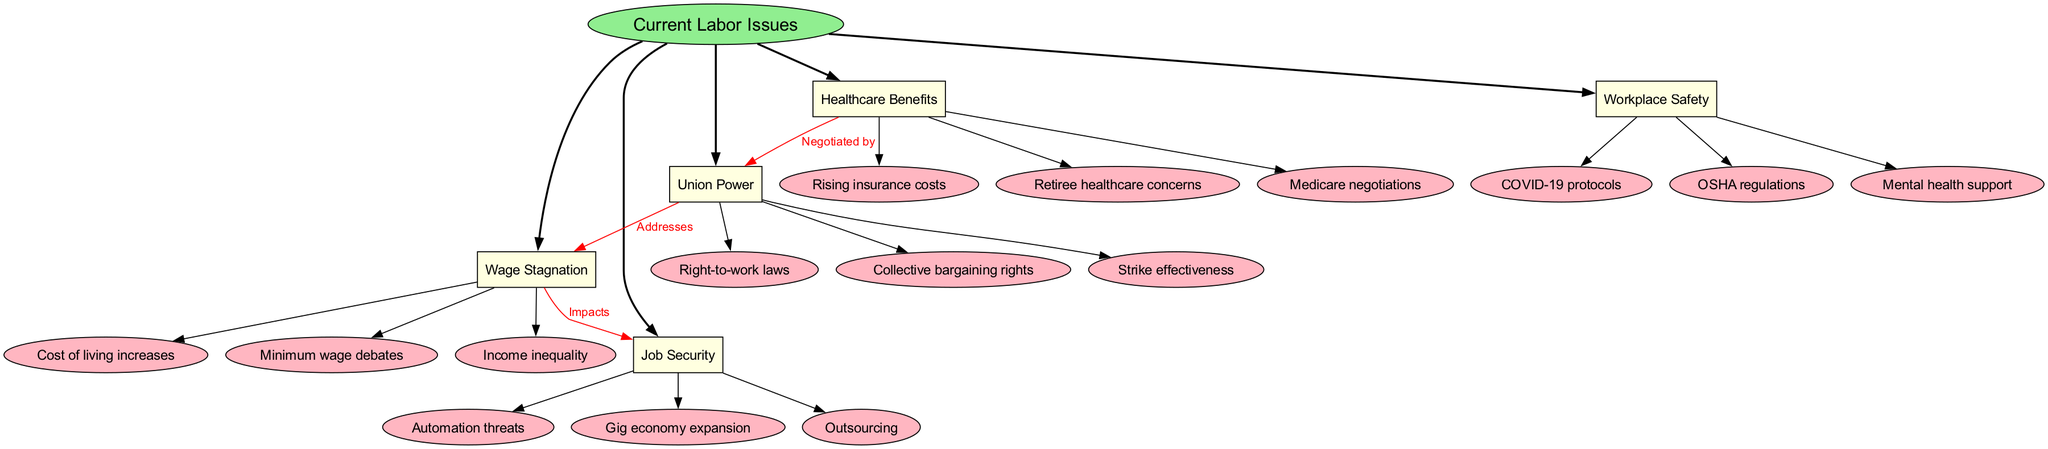What are the main branches of current labor issues? The diagram displays several main branches that connect to the central concept of "Current Labor Issues." These branches are: "Wage Stagnation," "Job Security," "Healthcare Benefits," "Union Power," and "Workplace Safety."
Answer: Wage Stagnation, Job Security, Healthcare Benefits, Union Power, Workplace Safety How many sub-branches are there under "Wage Stagnation"? Under "Wage Stagnation," there are three sub-branches listed: "Cost of living increases," "Minimum wage debates," and "Income inequality." Therefore, the count is three.
Answer: 3 What type of laws are connected to "Union Power"? The connection labeled "Right-to-work laws" is directly related to "Union Power" as its sub-branch, indicating it is a type of law affecting union strength.
Answer: Right-to-work laws What is the relationship between "Wage Stagnation" and "Job Security"? The diagram indicates an "Impacts" connection from "Wage Stagnation" to "Job Security," showing that issues in wage stagnation have an impact on the security of jobs.
Answer: Impacts Which sub-branch under "Healthcare Benefits" relates to union power? The sub-branch "Negotiated by" under "Healthcare Benefits" connects to "Union Power," indicating that healthcare benefits are typically negotiated by unions.
Answer: Negotiated by Which main branch addresses "Wage Stagnation"? The diagram shows that "Union Power" has an "Addresses" connection to "Wage Stagnation," which indicates that union actions are intended to handle or resolve issues around wage stagnation.
Answer: Union Power How many total main branches are there? The diagram lists a total of five main branches, each connecting to the central concept of current labor issues. These are distinct branches that categorize various issues affecting labor.
Answer: 5 What are the two factors that contribute to "Job Security"? Within the sub-branches of "Job Security," two contributing factors can be identified: "Automation threats" and "Gig economy expansion." These factors highlight significant modern challenges to job stability.
Answer: Automation threats, Gig economy expansion What type of regulations are represented under "Workplace Safety"? The sub-branches under "Workplace Safety" include "COVID-19 protocols," "OSHA regulations," and "Mental health support," indicating various types of safety regulations affecting workplaces.
Answer: COVID-19 protocols, OSHA regulations, Mental health support 